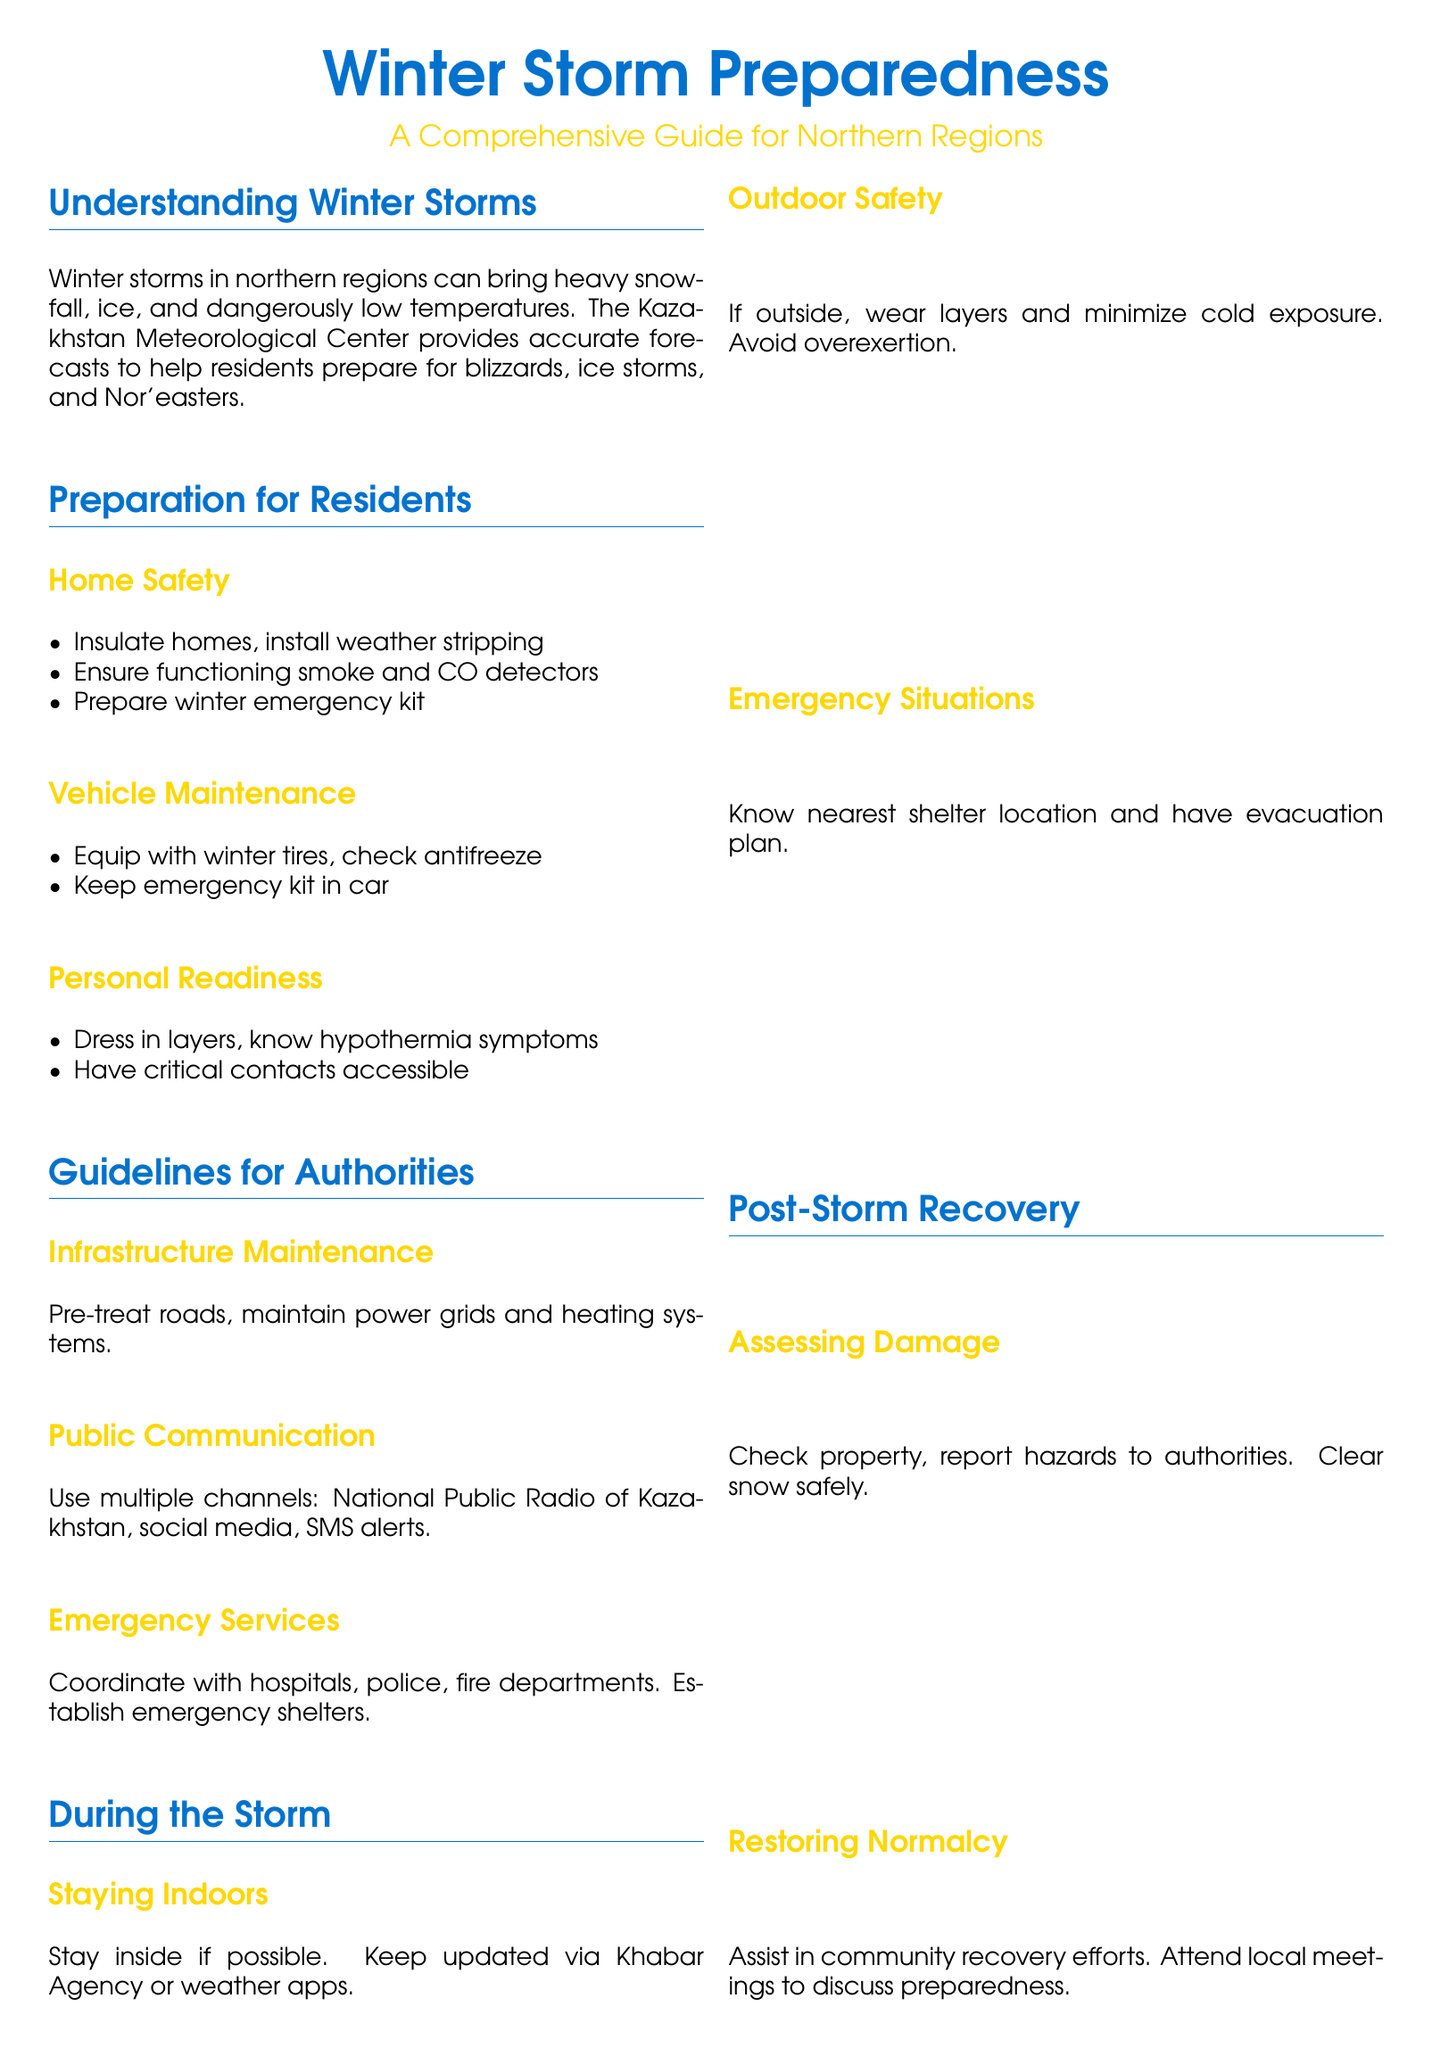What is the title of the document? The title is prominently displayed at the top of the document, which is "Winter Storm Preparedness".
Answer: Winter Storm Preparedness How does the Kazakhstan Meteorological Center contribute to winter storm preparedness? The Center provides accurate forecasts to help residents prepare for winter storms in northern regions.
Answer: Accurate forecasts What should residents include in their winter emergency kit? The document does not specify items in the kit, but emphasizes the importance of having one.
Answer: Winter emergency kit What should be checked in vehicles for winter safety? The document mentions that vehicles should be equipped with winter tires and check antifreeze.
Answer: Winter tires and antifreeze What is one guideline for infrastructure maintenance by authorities? The document suggests pre-treating roads as a maintenance guideline for authorities.
Answer: Pre-treat roads Which organization is mentioned for public communication during storms? The document specifically mentions the National Public Radio of Kazakhstan for this purpose.
Answer: National Public Radio of Kazakhstan What should one do if they must go outside during a storm? The document advises wearing layers and minimizing cold exposure.
Answer: Wear layers and minimize cold exposure What is the focus during post-storm recovery? The document emphasizes assisting in community recovery efforts and attending local meetings.
Answer: Community recovery efforts What color is used for the main title in the document? The main title is in the color defined as kazakblue.
Answer: Kazakblue 